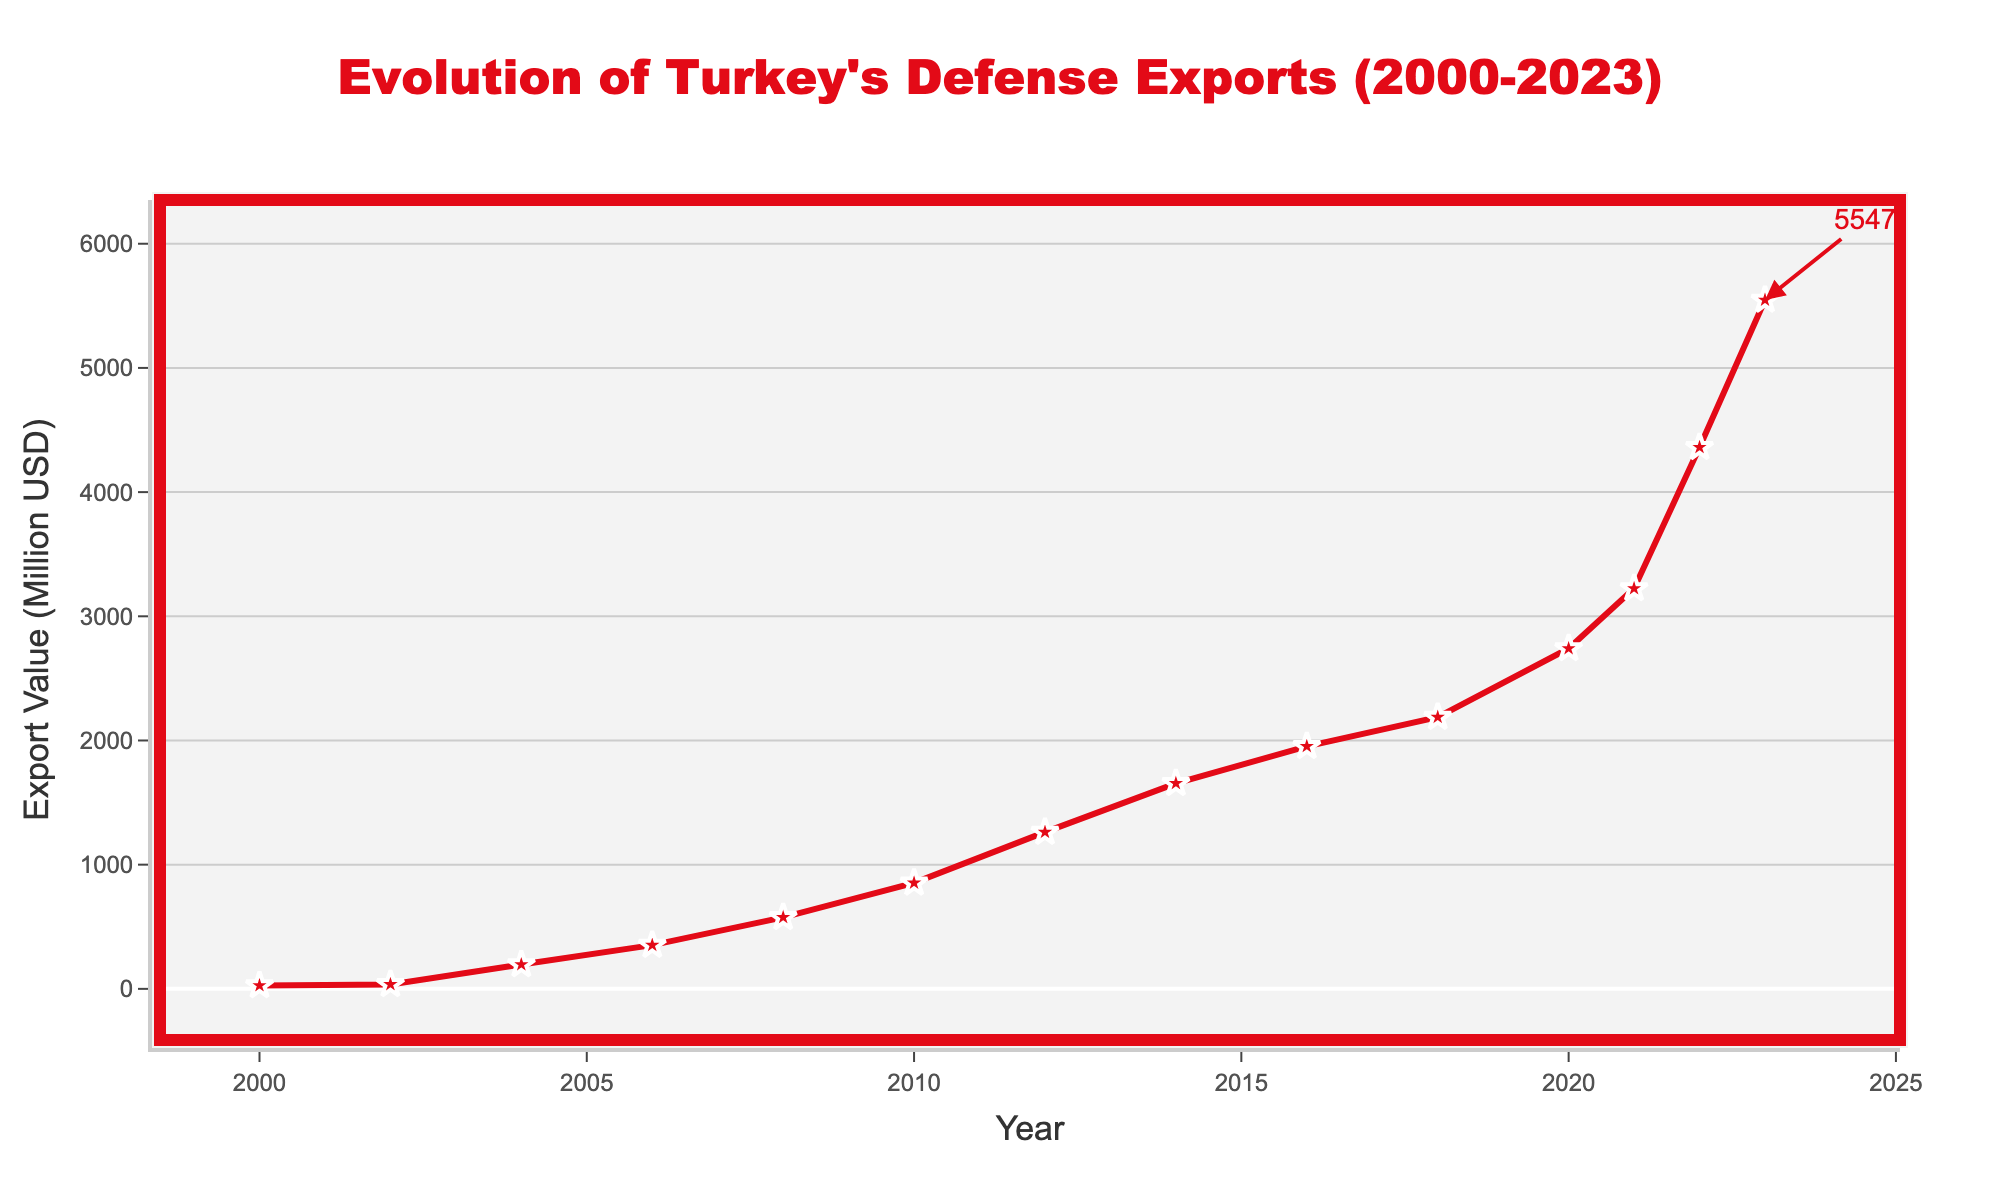What's the highest export value achieved in the given period? Look at the graph and identify the peak. The highest export value is marked with an annotation. The year 2023 has the highest value of 5547 million USD.
Answer: 5547 million USD By how much did Turkey's defense exports increase from 2002 to 2023? Find the export values for 2002 and 2023 in the chart. Subtract the 2002 value from the 2023 value. The difference is 5547 - 36 = 5511 million USD.
Answer: 5511 million USD What was the average export value between 2010 and 2020? Sum the export values for the years 2010, 2012, 2014, 2016, 2018, and 2020, then divide by the number of data points (6). (853+1262+1655+1953+2188+2741)/6 = 17642/6 = 2940.33 million USD
Answer: 2940.33 million USD During which year did Turkey's defense exports first exceed 1000 million USD? Review the chart and note when the export value first crossed 1000 million USD. It exceeded this threshold in 2012 with 1262 million USD.
Answer: 2012 What was the percentage increase in export value from 2021 to 2023? Find the export values for 2021 and 2023. Calculate the percentage increase: ((5547 - 3224) / 3224) * 100 = 72.03%.
Answer: 72.03% Which year saw the largest year-over-year increase in export value, and what was this increase? Calculate the year-over-year differences for each year and identify the largest one. The largest increase was from 2021 to 2022, with an increase of 4361 - 3224 = 1137 million USD.
Answer: 2022, 1137 million USD How many years did it take for Turkey's defense exports to go from 1000 million USD to 5000 million USD? Identify the first year when exports exceeded 1000 million (2012) and the first year when they exceeded 5000 million (2023). Calculate the difference in years: 2023 - 2012 = 11 years.
Answer: 11 years Compare the export values of 2008 and 2010. Which year had a higher value and by how much? Locate the values for 2008 (576 million USD) and 2010 (853 million USD). Calculate the difference (853 - 576 = 277 million USD) and see which is higher. 2010 has a higher value by 277 million USD.
Answer: 2010, 277 million USD Between which consecutive years did Turkey experience the smallest increase in defense export value? Calculate the year-over-year increases and identify the minimum. The smallest increase was from 2010 to 2012 with an increase of 1262 - 853 = 409 million USD.
Answer: 2010-2012, 409 million USD 